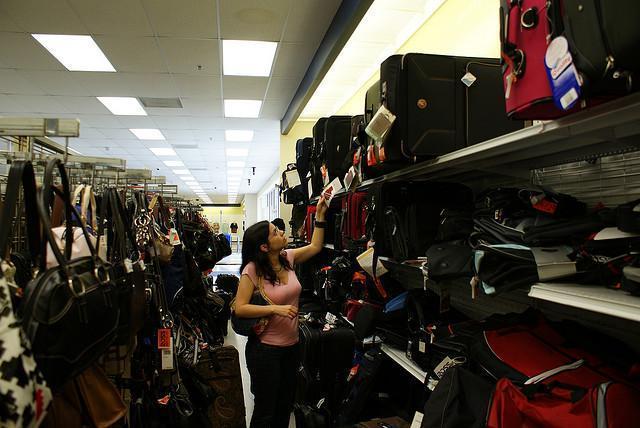How many handbags are there?
Give a very brief answer. 6. How many suitcases can be seen?
Give a very brief answer. 6. 